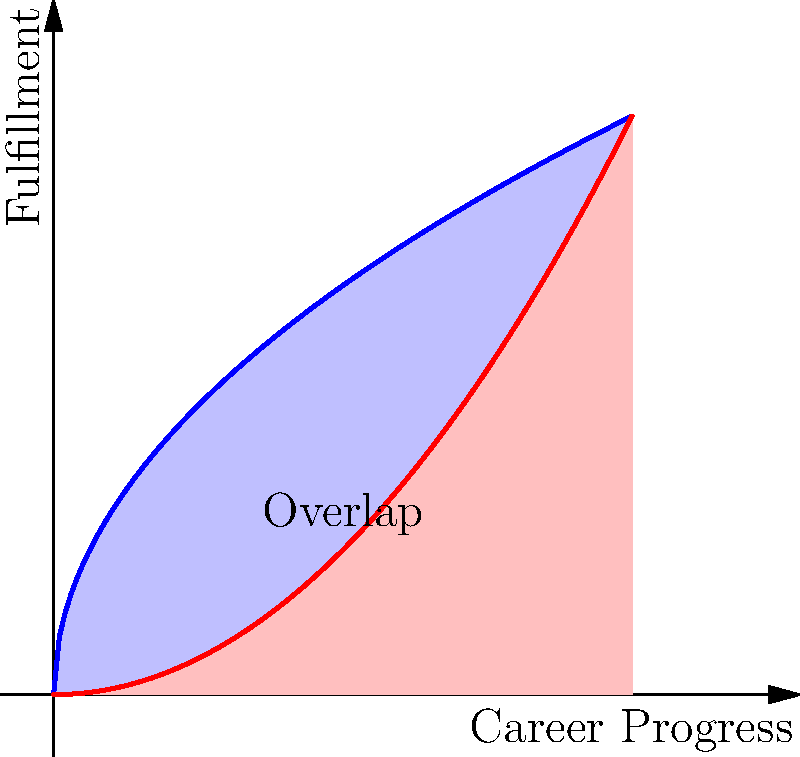In the graph above, the blue curve represents passion in a career, given by the function $f(x) = 2\sqrt{x}$, while the red curve represents practicality, given by the function $g(x) = \frac{x^2}{4}$. The x-axis represents career progress, and the y-axis represents fulfillment. Calculate the area of the region where passion and practicality overlap (the area between the two curves from their point of intersection to $x = 4$). What does this area represent in terms of career choices? To solve this problem, we'll follow these steps:

1) Find the point of intersection of the two curves:
   $2\sqrt{x} = \frac{x^2}{4}$
   $8\sqrt{x} = x^2$
   $64x = x^4$
   $x^4 - 64x = 0$
   $x(x^3 - 64) = 0$
   $x = 0$ or $x = 4$
   The relevant point of intersection is (4, 4).

2) Set up the integral to calculate the area between the curves:
   Area = $\int_0^4 (2\sqrt{x} - \frac{x^2}{4}) dx$

3) Solve the integral:
   $\int_0^4 (2\sqrt{x} - \frac{x^2}{4}) dx$
   $= [2\cdot\frac{2}{3}x^{3/2} - \frac{1}{12}x^3]_0^4$
   $= [\frac{4}{3}x^{3/2} - \frac{1}{12}x^3]_0^4$
   $= (\frac{4}{3}\cdot8 - \frac{1}{12}\cdot64) - (0 - 0)$
   $= \frac{32}{3} - \frac{16}{3}$
   $= \frac{16}{3}$

4) Interpret the result:
   The area of overlap is $\frac{16}{3}$ square units. This represents the balance between passion and practicality in career choices. A larger overlap suggests more opportunities where one can pursue their passion while maintaining practicality in their career decisions.
Answer: $\frac{16}{3}$ square units 